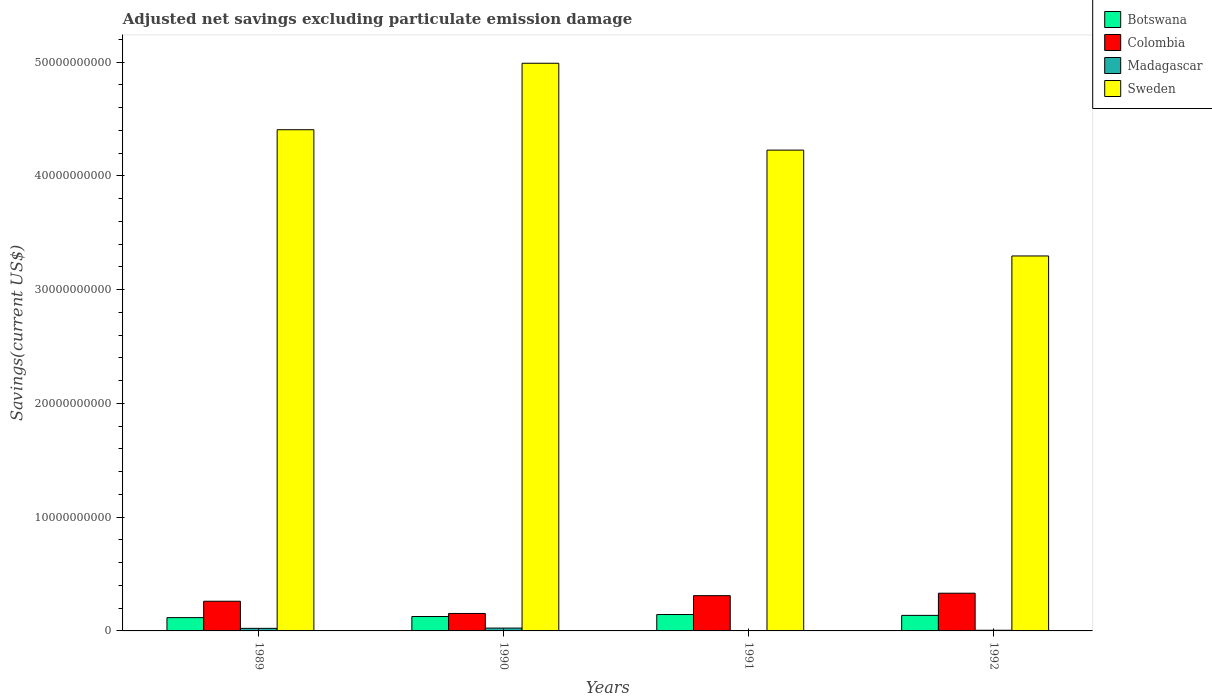How many different coloured bars are there?
Your response must be concise. 4. How many groups of bars are there?
Give a very brief answer. 4. How many bars are there on the 1st tick from the left?
Provide a short and direct response. 4. How many bars are there on the 3rd tick from the right?
Provide a short and direct response. 4. What is the label of the 4th group of bars from the left?
Your response must be concise. 1992. In how many cases, is the number of bars for a given year not equal to the number of legend labels?
Your answer should be very brief. 1. What is the adjusted net savings in Colombia in 1989?
Give a very brief answer. 2.61e+09. Across all years, what is the maximum adjusted net savings in Colombia?
Offer a very short reply. 3.32e+09. Across all years, what is the minimum adjusted net savings in Botswana?
Offer a terse response. 1.17e+09. In which year was the adjusted net savings in Botswana maximum?
Your answer should be compact. 1991. What is the total adjusted net savings in Botswana in the graph?
Your response must be concise. 5.24e+09. What is the difference between the adjusted net savings in Sweden in 1990 and that in 1991?
Provide a short and direct response. 7.64e+09. What is the difference between the adjusted net savings in Sweden in 1989 and the adjusted net savings in Madagascar in 1990?
Make the answer very short. 4.38e+1. What is the average adjusted net savings in Botswana per year?
Offer a very short reply. 1.31e+09. In the year 1989, what is the difference between the adjusted net savings in Botswana and adjusted net savings in Sweden?
Offer a terse response. -4.29e+1. What is the ratio of the adjusted net savings in Madagascar in 1989 to that in 1990?
Ensure brevity in your answer.  0.91. Is the adjusted net savings in Colombia in 1989 less than that in 1992?
Make the answer very short. Yes. What is the difference between the highest and the second highest adjusted net savings in Colombia?
Make the answer very short. 2.16e+08. What is the difference between the highest and the lowest adjusted net savings in Colombia?
Keep it short and to the point. 1.78e+09. In how many years, is the adjusted net savings in Madagascar greater than the average adjusted net savings in Madagascar taken over all years?
Ensure brevity in your answer.  2. Is the sum of the adjusted net savings in Sweden in 1991 and 1992 greater than the maximum adjusted net savings in Botswana across all years?
Keep it short and to the point. Yes. How many bars are there?
Make the answer very short. 15. What is the difference between two consecutive major ticks on the Y-axis?
Provide a short and direct response. 1.00e+1. Are the values on the major ticks of Y-axis written in scientific E-notation?
Your answer should be compact. No. Where does the legend appear in the graph?
Your response must be concise. Top right. How many legend labels are there?
Keep it short and to the point. 4. What is the title of the graph?
Offer a terse response. Adjusted net savings excluding particulate emission damage. What is the label or title of the X-axis?
Your answer should be compact. Years. What is the label or title of the Y-axis?
Give a very brief answer. Savings(current US$). What is the Savings(current US$) in Botswana in 1989?
Provide a succinct answer. 1.17e+09. What is the Savings(current US$) in Colombia in 1989?
Give a very brief answer. 2.61e+09. What is the Savings(current US$) in Madagascar in 1989?
Provide a short and direct response. 2.26e+08. What is the Savings(current US$) of Sweden in 1989?
Offer a very short reply. 4.41e+1. What is the Savings(current US$) in Botswana in 1990?
Make the answer very short. 1.27e+09. What is the Savings(current US$) in Colombia in 1990?
Offer a terse response. 1.54e+09. What is the Savings(current US$) in Madagascar in 1990?
Your answer should be very brief. 2.49e+08. What is the Savings(current US$) in Sweden in 1990?
Give a very brief answer. 4.99e+1. What is the Savings(current US$) in Botswana in 1991?
Keep it short and to the point. 1.44e+09. What is the Savings(current US$) of Colombia in 1991?
Provide a succinct answer. 3.10e+09. What is the Savings(current US$) of Madagascar in 1991?
Keep it short and to the point. 0. What is the Savings(current US$) of Sweden in 1991?
Your answer should be compact. 4.23e+1. What is the Savings(current US$) of Botswana in 1992?
Give a very brief answer. 1.37e+09. What is the Savings(current US$) of Colombia in 1992?
Offer a terse response. 3.32e+09. What is the Savings(current US$) of Madagascar in 1992?
Your response must be concise. 5.88e+07. What is the Savings(current US$) in Sweden in 1992?
Provide a short and direct response. 3.30e+1. Across all years, what is the maximum Savings(current US$) in Botswana?
Offer a terse response. 1.44e+09. Across all years, what is the maximum Savings(current US$) of Colombia?
Provide a short and direct response. 3.32e+09. Across all years, what is the maximum Savings(current US$) in Madagascar?
Give a very brief answer. 2.49e+08. Across all years, what is the maximum Savings(current US$) of Sweden?
Give a very brief answer. 4.99e+1. Across all years, what is the minimum Savings(current US$) in Botswana?
Offer a terse response. 1.17e+09. Across all years, what is the minimum Savings(current US$) in Colombia?
Your answer should be compact. 1.54e+09. Across all years, what is the minimum Savings(current US$) in Madagascar?
Offer a terse response. 0. Across all years, what is the minimum Savings(current US$) in Sweden?
Keep it short and to the point. 3.30e+1. What is the total Savings(current US$) of Botswana in the graph?
Your response must be concise. 5.24e+09. What is the total Savings(current US$) in Colombia in the graph?
Provide a short and direct response. 1.06e+1. What is the total Savings(current US$) of Madagascar in the graph?
Provide a short and direct response. 5.34e+08. What is the total Savings(current US$) of Sweden in the graph?
Make the answer very short. 1.69e+11. What is the difference between the Savings(current US$) in Botswana in 1989 and that in 1990?
Provide a succinct answer. -9.68e+07. What is the difference between the Savings(current US$) of Colombia in 1989 and that in 1990?
Your response must be concise. 1.07e+09. What is the difference between the Savings(current US$) in Madagascar in 1989 and that in 1990?
Offer a very short reply. -2.25e+07. What is the difference between the Savings(current US$) of Sweden in 1989 and that in 1990?
Your answer should be very brief. -5.84e+09. What is the difference between the Savings(current US$) of Botswana in 1989 and that in 1991?
Make the answer very short. -2.72e+08. What is the difference between the Savings(current US$) of Colombia in 1989 and that in 1991?
Your response must be concise. -4.90e+08. What is the difference between the Savings(current US$) in Sweden in 1989 and that in 1991?
Keep it short and to the point. 1.79e+09. What is the difference between the Savings(current US$) of Botswana in 1989 and that in 1992?
Your answer should be compact. -1.97e+08. What is the difference between the Savings(current US$) in Colombia in 1989 and that in 1992?
Your answer should be very brief. -7.06e+08. What is the difference between the Savings(current US$) of Madagascar in 1989 and that in 1992?
Keep it short and to the point. 1.68e+08. What is the difference between the Savings(current US$) in Sweden in 1989 and that in 1992?
Your answer should be compact. 1.11e+1. What is the difference between the Savings(current US$) in Botswana in 1990 and that in 1991?
Provide a succinct answer. -1.75e+08. What is the difference between the Savings(current US$) of Colombia in 1990 and that in 1991?
Offer a very short reply. -1.56e+09. What is the difference between the Savings(current US$) of Sweden in 1990 and that in 1991?
Keep it short and to the point. 7.64e+09. What is the difference between the Savings(current US$) in Botswana in 1990 and that in 1992?
Offer a terse response. -1.01e+08. What is the difference between the Savings(current US$) in Colombia in 1990 and that in 1992?
Your response must be concise. -1.78e+09. What is the difference between the Savings(current US$) in Madagascar in 1990 and that in 1992?
Give a very brief answer. 1.90e+08. What is the difference between the Savings(current US$) in Sweden in 1990 and that in 1992?
Offer a very short reply. 1.69e+1. What is the difference between the Savings(current US$) in Botswana in 1991 and that in 1992?
Your answer should be compact. 7.46e+07. What is the difference between the Savings(current US$) of Colombia in 1991 and that in 1992?
Your response must be concise. -2.16e+08. What is the difference between the Savings(current US$) of Sweden in 1991 and that in 1992?
Make the answer very short. 9.31e+09. What is the difference between the Savings(current US$) in Botswana in 1989 and the Savings(current US$) in Colombia in 1990?
Your answer should be compact. -3.67e+08. What is the difference between the Savings(current US$) in Botswana in 1989 and the Savings(current US$) in Madagascar in 1990?
Make the answer very short. 9.20e+08. What is the difference between the Savings(current US$) in Botswana in 1989 and the Savings(current US$) in Sweden in 1990?
Your answer should be very brief. -4.87e+1. What is the difference between the Savings(current US$) in Colombia in 1989 and the Savings(current US$) in Madagascar in 1990?
Your response must be concise. 2.36e+09. What is the difference between the Savings(current US$) of Colombia in 1989 and the Savings(current US$) of Sweden in 1990?
Give a very brief answer. -4.73e+1. What is the difference between the Savings(current US$) of Madagascar in 1989 and the Savings(current US$) of Sweden in 1990?
Your response must be concise. -4.97e+1. What is the difference between the Savings(current US$) in Botswana in 1989 and the Savings(current US$) in Colombia in 1991?
Keep it short and to the point. -1.93e+09. What is the difference between the Savings(current US$) in Botswana in 1989 and the Savings(current US$) in Sweden in 1991?
Ensure brevity in your answer.  -4.11e+1. What is the difference between the Savings(current US$) in Colombia in 1989 and the Savings(current US$) in Sweden in 1991?
Your answer should be very brief. -3.97e+1. What is the difference between the Savings(current US$) of Madagascar in 1989 and the Savings(current US$) of Sweden in 1991?
Your answer should be very brief. -4.20e+1. What is the difference between the Savings(current US$) of Botswana in 1989 and the Savings(current US$) of Colombia in 1992?
Offer a very short reply. -2.15e+09. What is the difference between the Savings(current US$) in Botswana in 1989 and the Savings(current US$) in Madagascar in 1992?
Offer a very short reply. 1.11e+09. What is the difference between the Savings(current US$) in Botswana in 1989 and the Savings(current US$) in Sweden in 1992?
Provide a short and direct response. -3.18e+1. What is the difference between the Savings(current US$) of Colombia in 1989 and the Savings(current US$) of Madagascar in 1992?
Your response must be concise. 2.55e+09. What is the difference between the Savings(current US$) of Colombia in 1989 and the Savings(current US$) of Sweden in 1992?
Your answer should be compact. -3.04e+1. What is the difference between the Savings(current US$) in Madagascar in 1989 and the Savings(current US$) in Sweden in 1992?
Offer a terse response. -3.27e+1. What is the difference between the Savings(current US$) in Botswana in 1990 and the Savings(current US$) in Colombia in 1991?
Offer a very short reply. -1.83e+09. What is the difference between the Savings(current US$) of Botswana in 1990 and the Savings(current US$) of Sweden in 1991?
Provide a succinct answer. -4.10e+1. What is the difference between the Savings(current US$) in Colombia in 1990 and the Savings(current US$) in Sweden in 1991?
Offer a very short reply. -4.07e+1. What is the difference between the Savings(current US$) of Madagascar in 1990 and the Savings(current US$) of Sweden in 1991?
Provide a succinct answer. -4.20e+1. What is the difference between the Savings(current US$) of Botswana in 1990 and the Savings(current US$) of Colombia in 1992?
Offer a very short reply. -2.05e+09. What is the difference between the Savings(current US$) in Botswana in 1990 and the Savings(current US$) in Madagascar in 1992?
Keep it short and to the point. 1.21e+09. What is the difference between the Savings(current US$) of Botswana in 1990 and the Savings(current US$) of Sweden in 1992?
Ensure brevity in your answer.  -3.17e+1. What is the difference between the Savings(current US$) of Colombia in 1990 and the Savings(current US$) of Madagascar in 1992?
Offer a very short reply. 1.48e+09. What is the difference between the Savings(current US$) of Colombia in 1990 and the Savings(current US$) of Sweden in 1992?
Offer a terse response. -3.14e+1. What is the difference between the Savings(current US$) of Madagascar in 1990 and the Savings(current US$) of Sweden in 1992?
Make the answer very short. -3.27e+1. What is the difference between the Savings(current US$) of Botswana in 1991 and the Savings(current US$) of Colombia in 1992?
Provide a short and direct response. -1.87e+09. What is the difference between the Savings(current US$) in Botswana in 1991 and the Savings(current US$) in Madagascar in 1992?
Your answer should be compact. 1.38e+09. What is the difference between the Savings(current US$) of Botswana in 1991 and the Savings(current US$) of Sweden in 1992?
Your answer should be very brief. -3.15e+1. What is the difference between the Savings(current US$) in Colombia in 1991 and the Savings(current US$) in Madagascar in 1992?
Provide a short and direct response. 3.04e+09. What is the difference between the Savings(current US$) in Colombia in 1991 and the Savings(current US$) in Sweden in 1992?
Give a very brief answer. -2.99e+1. What is the average Savings(current US$) of Botswana per year?
Make the answer very short. 1.31e+09. What is the average Savings(current US$) in Colombia per year?
Provide a short and direct response. 2.64e+09. What is the average Savings(current US$) in Madagascar per year?
Keep it short and to the point. 1.33e+08. What is the average Savings(current US$) in Sweden per year?
Provide a succinct answer. 4.23e+1. In the year 1989, what is the difference between the Savings(current US$) in Botswana and Savings(current US$) in Colombia?
Offer a very short reply. -1.44e+09. In the year 1989, what is the difference between the Savings(current US$) in Botswana and Savings(current US$) in Madagascar?
Make the answer very short. 9.43e+08. In the year 1989, what is the difference between the Savings(current US$) of Botswana and Savings(current US$) of Sweden?
Provide a succinct answer. -4.29e+1. In the year 1989, what is the difference between the Savings(current US$) in Colombia and Savings(current US$) in Madagascar?
Your answer should be compact. 2.38e+09. In the year 1989, what is the difference between the Savings(current US$) in Colombia and Savings(current US$) in Sweden?
Keep it short and to the point. -4.15e+1. In the year 1989, what is the difference between the Savings(current US$) in Madagascar and Savings(current US$) in Sweden?
Offer a terse response. -4.38e+1. In the year 1990, what is the difference between the Savings(current US$) of Botswana and Savings(current US$) of Colombia?
Keep it short and to the point. -2.70e+08. In the year 1990, what is the difference between the Savings(current US$) of Botswana and Savings(current US$) of Madagascar?
Provide a succinct answer. 1.02e+09. In the year 1990, what is the difference between the Savings(current US$) in Botswana and Savings(current US$) in Sweden?
Provide a short and direct response. -4.86e+1. In the year 1990, what is the difference between the Savings(current US$) of Colombia and Savings(current US$) of Madagascar?
Provide a short and direct response. 1.29e+09. In the year 1990, what is the difference between the Savings(current US$) in Colombia and Savings(current US$) in Sweden?
Provide a succinct answer. -4.84e+1. In the year 1990, what is the difference between the Savings(current US$) of Madagascar and Savings(current US$) of Sweden?
Ensure brevity in your answer.  -4.97e+1. In the year 1991, what is the difference between the Savings(current US$) of Botswana and Savings(current US$) of Colombia?
Your answer should be very brief. -1.66e+09. In the year 1991, what is the difference between the Savings(current US$) in Botswana and Savings(current US$) in Sweden?
Provide a short and direct response. -4.08e+1. In the year 1991, what is the difference between the Savings(current US$) in Colombia and Savings(current US$) in Sweden?
Make the answer very short. -3.92e+1. In the year 1992, what is the difference between the Savings(current US$) of Botswana and Savings(current US$) of Colombia?
Offer a very short reply. -1.95e+09. In the year 1992, what is the difference between the Savings(current US$) of Botswana and Savings(current US$) of Madagascar?
Provide a short and direct response. 1.31e+09. In the year 1992, what is the difference between the Savings(current US$) in Botswana and Savings(current US$) in Sweden?
Your answer should be compact. -3.16e+1. In the year 1992, what is the difference between the Savings(current US$) of Colombia and Savings(current US$) of Madagascar?
Make the answer very short. 3.26e+09. In the year 1992, what is the difference between the Savings(current US$) in Colombia and Savings(current US$) in Sweden?
Make the answer very short. -2.96e+1. In the year 1992, what is the difference between the Savings(current US$) of Madagascar and Savings(current US$) of Sweden?
Your answer should be very brief. -3.29e+1. What is the ratio of the Savings(current US$) in Botswana in 1989 to that in 1990?
Your response must be concise. 0.92. What is the ratio of the Savings(current US$) of Colombia in 1989 to that in 1990?
Offer a terse response. 1.7. What is the ratio of the Savings(current US$) in Madagascar in 1989 to that in 1990?
Your response must be concise. 0.91. What is the ratio of the Savings(current US$) in Sweden in 1989 to that in 1990?
Keep it short and to the point. 0.88. What is the ratio of the Savings(current US$) in Botswana in 1989 to that in 1991?
Your answer should be very brief. 0.81. What is the ratio of the Savings(current US$) in Colombia in 1989 to that in 1991?
Your answer should be compact. 0.84. What is the ratio of the Savings(current US$) in Sweden in 1989 to that in 1991?
Your answer should be very brief. 1.04. What is the ratio of the Savings(current US$) of Botswana in 1989 to that in 1992?
Keep it short and to the point. 0.86. What is the ratio of the Savings(current US$) of Colombia in 1989 to that in 1992?
Make the answer very short. 0.79. What is the ratio of the Savings(current US$) of Madagascar in 1989 to that in 1992?
Provide a succinct answer. 3.85. What is the ratio of the Savings(current US$) in Sweden in 1989 to that in 1992?
Ensure brevity in your answer.  1.34. What is the ratio of the Savings(current US$) in Botswana in 1990 to that in 1991?
Your response must be concise. 0.88. What is the ratio of the Savings(current US$) of Colombia in 1990 to that in 1991?
Offer a very short reply. 0.5. What is the ratio of the Savings(current US$) of Sweden in 1990 to that in 1991?
Make the answer very short. 1.18. What is the ratio of the Savings(current US$) in Botswana in 1990 to that in 1992?
Keep it short and to the point. 0.93. What is the ratio of the Savings(current US$) in Colombia in 1990 to that in 1992?
Your answer should be compact. 0.46. What is the ratio of the Savings(current US$) in Madagascar in 1990 to that in 1992?
Offer a very short reply. 4.23. What is the ratio of the Savings(current US$) in Sweden in 1990 to that in 1992?
Your answer should be very brief. 1.51. What is the ratio of the Savings(current US$) in Botswana in 1991 to that in 1992?
Provide a succinct answer. 1.05. What is the ratio of the Savings(current US$) in Colombia in 1991 to that in 1992?
Offer a very short reply. 0.93. What is the ratio of the Savings(current US$) in Sweden in 1991 to that in 1992?
Ensure brevity in your answer.  1.28. What is the difference between the highest and the second highest Savings(current US$) of Botswana?
Offer a terse response. 7.46e+07. What is the difference between the highest and the second highest Savings(current US$) of Colombia?
Give a very brief answer. 2.16e+08. What is the difference between the highest and the second highest Savings(current US$) of Madagascar?
Offer a terse response. 2.25e+07. What is the difference between the highest and the second highest Savings(current US$) in Sweden?
Offer a terse response. 5.84e+09. What is the difference between the highest and the lowest Savings(current US$) in Botswana?
Ensure brevity in your answer.  2.72e+08. What is the difference between the highest and the lowest Savings(current US$) in Colombia?
Provide a succinct answer. 1.78e+09. What is the difference between the highest and the lowest Savings(current US$) in Madagascar?
Your answer should be compact. 2.49e+08. What is the difference between the highest and the lowest Savings(current US$) of Sweden?
Your response must be concise. 1.69e+1. 